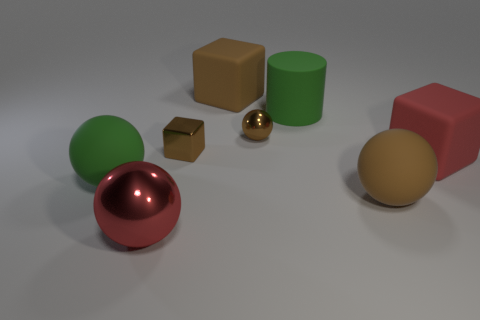What number of other things are there of the same material as the large brown ball
Provide a succinct answer. 4. How many things are either large green spheres behind the red metal object or big things that are to the left of the tiny cube?
Ensure brevity in your answer.  2. There is a tiny brown metal object behind the brown metal cube; is it the same shape as the red object on the right side of the tiny brown shiny sphere?
Give a very brief answer. No. The green thing that is the same size as the green matte sphere is what shape?
Offer a terse response. Cylinder. What number of matte objects are large blue objects or small brown balls?
Your answer should be very brief. 0. Is the big object in front of the brown rubber sphere made of the same material as the green thing that is on the right side of the green matte ball?
Your response must be concise. No. There is a large cylinder that is made of the same material as the big red cube; what color is it?
Offer a very short reply. Green. Are there more small brown balls that are left of the green ball than green things to the left of the rubber cylinder?
Your answer should be very brief. No. Are any green rubber cylinders visible?
Your answer should be compact. Yes. What is the material of the big sphere that is the same color as the small shiny ball?
Your answer should be compact. Rubber. 